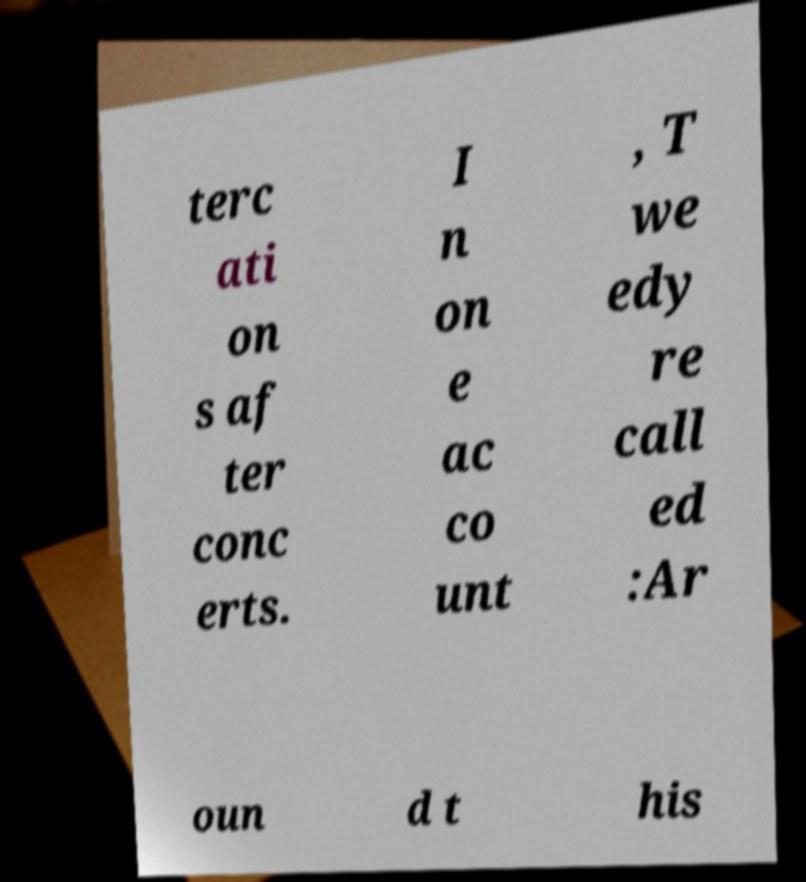Could you extract and type out the text from this image? terc ati on s af ter conc erts. I n on e ac co unt , T we edy re call ed :Ar oun d t his 